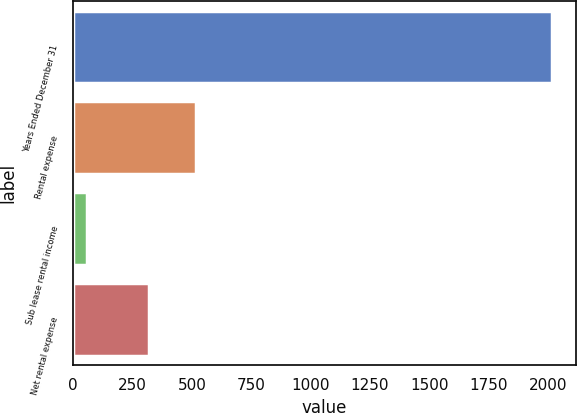<chart> <loc_0><loc_0><loc_500><loc_500><bar_chart><fcel>Years Ended December 31<fcel>Rental expense<fcel>Sub lease rental income<fcel>Net rental expense<nl><fcel>2017<fcel>516<fcel>57<fcel>320<nl></chart> 